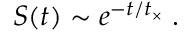Convert formula to latex. <formula><loc_0><loc_0><loc_500><loc_500>S ( t ) \sim e ^ { - t / t _ { \times } } \, .</formula> 